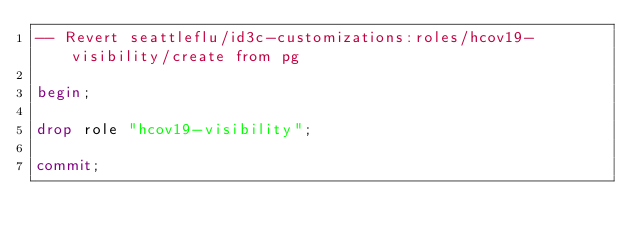<code> <loc_0><loc_0><loc_500><loc_500><_SQL_>-- Revert seattleflu/id3c-customizations:roles/hcov19-visibility/create from pg

begin;

drop role "hcov19-visibility";

commit;
</code> 